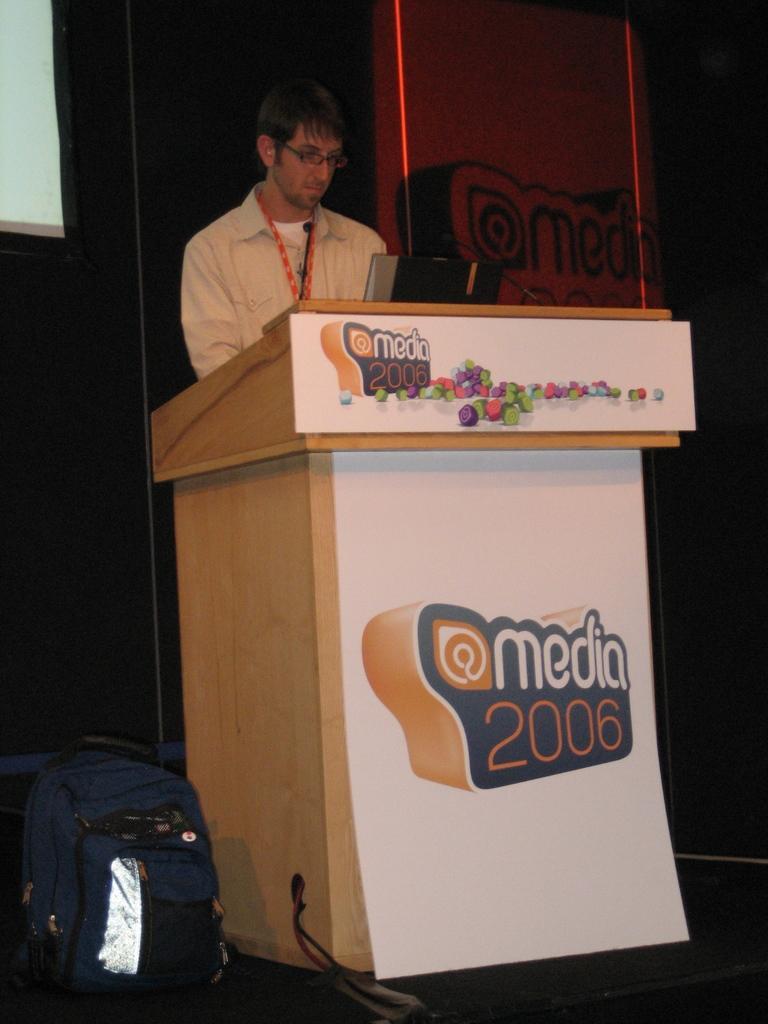Could you give a brief overview of what you see in this image? In this image I can see a man standing in front of the podium. There is a bag on the floor,in front of the man there is laptop. At the background I can see a screen. 